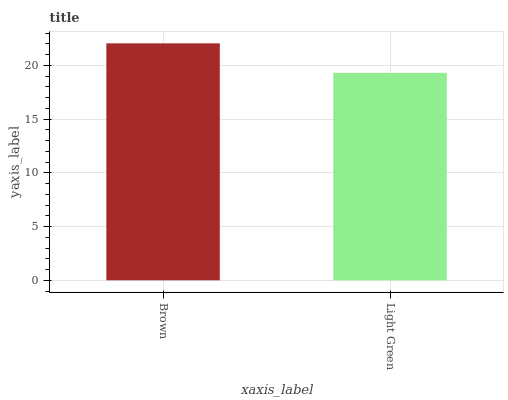Is Light Green the minimum?
Answer yes or no. Yes. Is Brown the maximum?
Answer yes or no. Yes. Is Light Green the maximum?
Answer yes or no. No. Is Brown greater than Light Green?
Answer yes or no. Yes. Is Light Green less than Brown?
Answer yes or no. Yes. Is Light Green greater than Brown?
Answer yes or no. No. Is Brown less than Light Green?
Answer yes or no. No. Is Brown the high median?
Answer yes or no. Yes. Is Light Green the low median?
Answer yes or no. Yes. Is Light Green the high median?
Answer yes or no. No. Is Brown the low median?
Answer yes or no. No. 